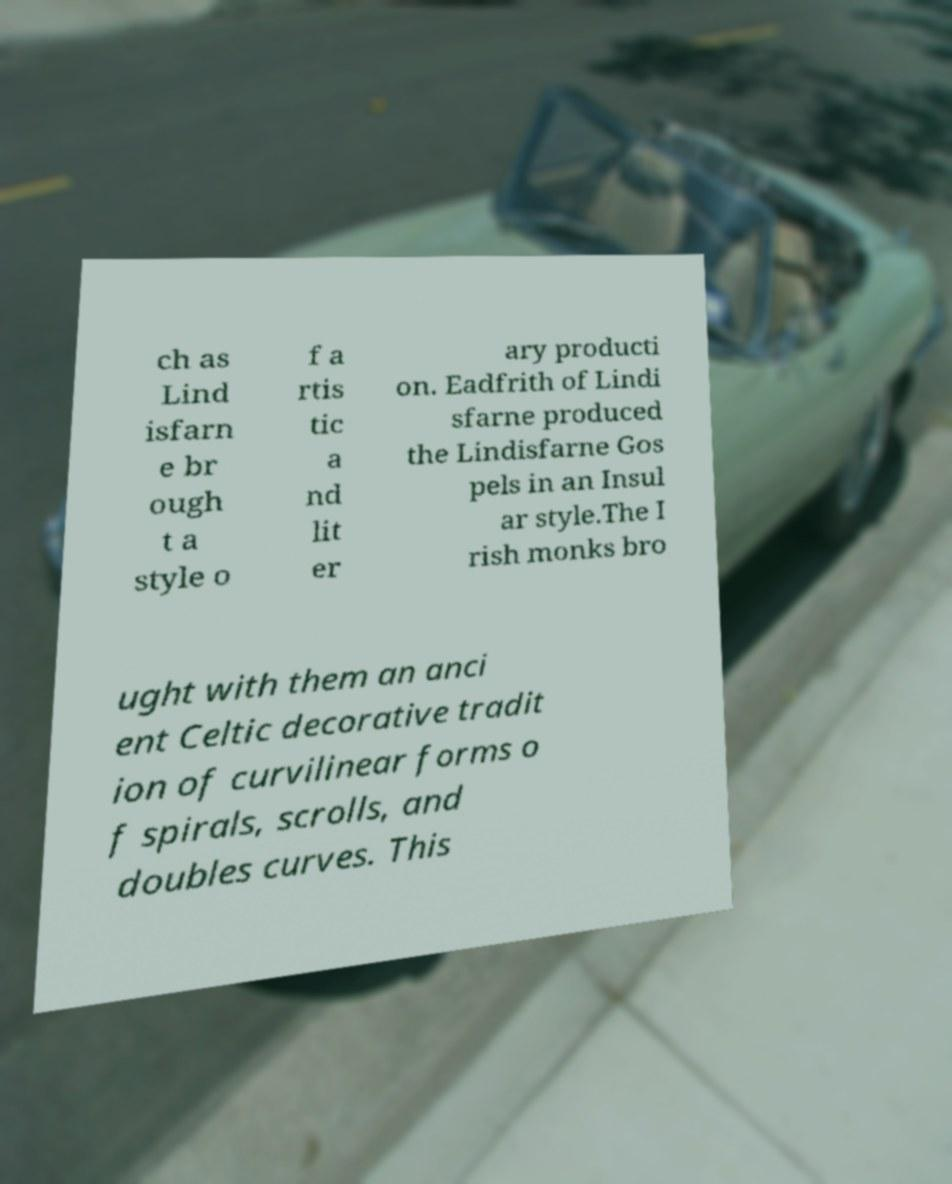What messages or text are displayed in this image? I need them in a readable, typed format. ch as Lind isfarn e br ough t a style o f a rtis tic a nd lit er ary producti on. Eadfrith of Lindi sfarne produced the Lindisfarne Gos pels in an Insul ar style.The I rish monks bro ught with them an anci ent Celtic decorative tradit ion of curvilinear forms o f spirals, scrolls, and doubles curves. This 